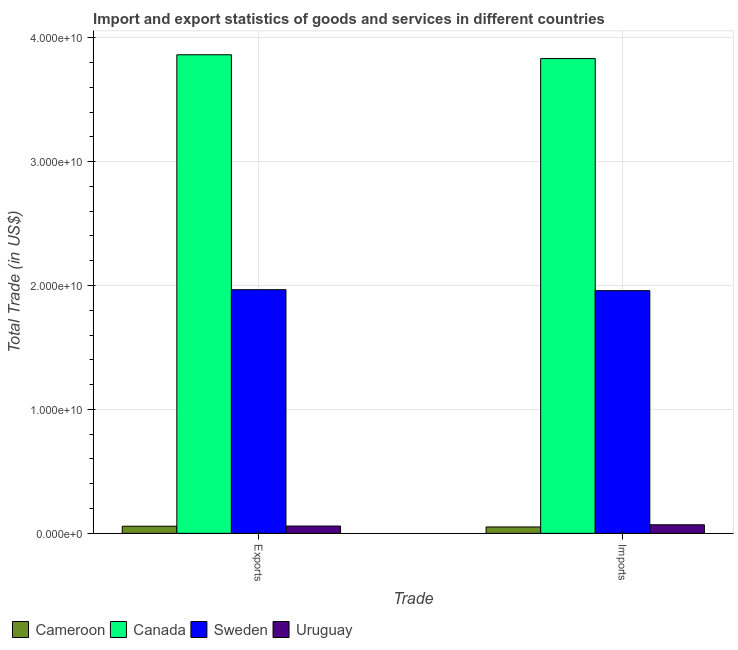How many groups of bars are there?
Your answer should be very brief. 2. Are the number of bars per tick equal to the number of legend labels?
Offer a very short reply. Yes. Are the number of bars on each tick of the X-axis equal?
Keep it short and to the point. Yes. How many bars are there on the 2nd tick from the left?
Your answer should be compact. 4. How many bars are there on the 2nd tick from the right?
Your answer should be very brief. 4. What is the label of the 2nd group of bars from the left?
Your response must be concise. Imports. What is the imports of goods and services in Sweden?
Give a very brief answer. 1.96e+1. Across all countries, what is the maximum imports of goods and services?
Make the answer very short. 3.83e+1. Across all countries, what is the minimum imports of goods and services?
Make the answer very short. 5.14e+08. In which country was the export of goods and services maximum?
Offer a very short reply. Canada. In which country was the imports of goods and services minimum?
Make the answer very short. Cameroon. What is the total export of goods and services in the graph?
Your response must be concise. 5.95e+1. What is the difference between the imports of goods and services in Cameroon and that in Uruguay?
Provide a succinct answer. -1.77e+08. What is the difference between the imports of goods and services in Uruguay and the export of goods and services in Cameroon?
Your response must be concise. 1.17e+08. What is the average imports of goods and services per country?
Ensure brevity in your answer.  1.48e+1. What is the difference between the imports of goods and services and export of goods and services in Canada?
Provide a succinct answer. -3.07e+08. What is the ratio of the imports of goods and services in Uruguay to that in Canada?
Keep it short and to the point. 0.02. What does the 1st bar from the right in Imports represents?
Offer a terse response. Uruguay. How many bars are there?
Make the answer very short. 8. Are all the bars in the graph horizontal?
Provide a succinct answer. No. What is the difference between two consecutive major ticks on the Y-axis?
Offer a very short reply. 1.00e+1. Are the values on the major ticks of Y-axis written in scientific E-notation?
Offer a very short reply. Yes. Does the graph contain any zero values?
Keep it short and to the point. No. Where does the legend appear in the graph?
Your answer should be compact. Bottom left. How many legend labels are there?
Keep it short and to the point. 4. How are the legend labels stacked?
Your answer should be compact. Horizontal. What is the title of the graph?
Keep it short and to the point. Import and export statistics of goods and services in different countries. What is the label or title of the X-axis?
Give a very brief answer. Trade. What is the label or title of the Y-axis?
Your answer should be very brief. Total Trade (in US$). What is the Total Trade (in US$) of Cameroon in Exports?
Provide a short and direct response. 5.74e+08. What is the Total Trade (in US$) in Canada in Exports?
Give a very brief answer. 3.86e+1. What is the Total Trade (in US$) in Sweden in Exports?
Give a very brief answer. 1.97e+1. What is the Total Trade (in US$) of Uruguay in Exports?
Your answer should be very brief. 5.88e+08. What is the Total Trade (in US$) of Cameroon in Imports?
Give a very brief answer. 5.14e+08. What is the Total Trade (in US$) in Canada in Imports?
Your response must be concise. 3.83e+1. What is the Total Trade (in US$) of Sweden in Imports?
Your response must be concise. 1.96e+1. What is the Total Trade (in US$) in Uruguay in Imports?
Ensure brevity in your answer.  6.91e+08. Across all Trade, what is the maximum Total Trade (in US$) in Cameroon?
Your response must be concise. 5.74e+08. Across all Trade, what is the maximum Total Trade (in US$) of Canada?
Offer a very short reply. 3.86e+1. Across all Trade, what is the maximum Total Trade (in US$) in Sweden?
Give a very brief answer. 1.97e+1. Across all Trade, what is the maximum Total Trade (in US$) of Uruguay?
Ensure brevity in your answer.  6.91e+08. Across all Trade, what is the minimum Total Trade (in US$) in Cameroon?
Give a very brief answer. 5.14e+08. Across all Trade, what is the minimum Total Trade (in US$) in Canada?
Ensure brevity in your answer.  3.83e+1. Across all Trade, what is the minimum Total Trade (in US$) of Sweden?
Your answer should be very brief. 1.96e+1. Across all Trade, what is the minimum Total Trade (in US$) in Uruguay?
Your answer should be compact. 5.88e+08. What is the total Total Trade (in US$) in Cameroon in the graph?
Ensure brevity in your answer.  1.09e+09. What is the total Total Trade (in US$) in Canada in the graph?
Ensure brevity in your answer.  7.69e+1. What is the total Total Trade (in US$) in Sweden in the graph?
Your response must be concise. 3.93e+1. What is the total Total Trade (in US$) of Uruguay in the graph?
Make the answer very short. 1.28e+09. What is the difference between the Total Trade (in US$) in Cameroon in Exports and that in Imports?
Your answer should be very brief. 5.95e+07. What is the difference between the Total Trade (in US$) of Canada in Exports and that in Imports?
Your answer should be very brief. 3.07e+08. What is the difference between the Total Trade (in US$) of Sweden in Exports and that in Imports?
Your answer should be compact. 7.82e+07. What is the difference between the Total Trade (in US$) in Uruguay in Exports and that in Imports?
Keep it short and to the point. -1.03e+08. What is the difference between the Total Trade (in US$) of Cameroon in Exports and the Total Trade (in US$) of Canada in Imports?
Your answer should be very brief. -3.77e+1. What is the difference between the Total Trade (in US$) in Cameroon in Exports and the Total Trade (in US$) in Sweden in Imports?
Provide a short and direct response. -1.90e+1. What is the difference between the Total Trade (in US$) in Cameroon in Exports and the Total Trade (in US$) in Uruguay in Imports?
Keep it short and to the point. -1.17e+08. What is the difference between the Total Trade (in US$) in Canada in Exports and the Total Trade (in US$) in Sweden in Imports?
Give a very brief answer. 1.90e+1. What is the difference between the Total Trade (in US$) in Canada in Exports and the Total Trade (in US$) in Uruguay in Imports?
Offer a terse response. 3.79e+1. What is the difference between the Total Trade (in US$) in Sweden in Exports and the Total Trade (in US$) in Uruguay in Imports?
Keep it short and to the point. 1.90e+1. What is the average Total Trade (in US$) in Cameroon per Trade?
Provide a short and direct response. 5.44e+08. What is the average Total Trade (in US$) of Canada per Trade?
Your response must be concise. 3.85e+1. What is the average Total Trade (in US$) in Sweden per Trade?
Ensure brevity in your answer.  1.96e+1. What is the average Total Trade (in US$) in Uruguay per Trade?
Make the answer very short. 6.40e+08. What is the difference between the Total Trade (in US$) in Cameroon and Total Trade (in US$) in Canada in Exports?
Your answer should be compact. -3.81e+1. What is the difference between the Total Trade (in US$) in Cameroon and Total Trade (in US$) in Sweden in Exports?
Your answer should be very brief. -1.91e+1. What is the difference between the Total Trade (in US$) of Cameroon and Total Trade (in US$) of Uruguay in Exports?
Keep it short and to the point. -1.45e+07. What is the difference between the Total Trade (in US$) in Canada and Total Trade (in US$) in Sweden in Exports?
Provide a short and direct response. 1.90e+1. What is the difference between the Total Trade (in US$) of Canada and Total Trade (in US$) of Uruguay in Exports?
Make the answer very short. 3.80e+1. What is the difference between the Total Trade (in US$) in Sweden and Total Trade (in US$) in Uruguay in Exports?
Your answer should be compact. 1.91e+1. What is the difference between the Total Trade (in US$) of Cameroon and Total Trade (in US$) of Canada in Imports?
Make the answer very short. -3.78e+1. What is the difference between the Total Trade (in US$) of Cameroon and Total Trade (in US$) of Sweden in Imports?
Offer a terse response. -1.91e+1. What is the difference between the Total Trade (in US$) in Cameroon and Total Trade (in US$) in Uruguay in Imports?
Keep it short and to the point. -1.77e+08. What is the difference between the Total Trade (in US$) of Canada and Total Trade (in US$) of Sweden in Imports?
Your answer should be very brief. 1.87e+1. What is the difference between the Total Trade (in US$) in Canada and Total Trade (in US$) in Uruguay in Imports?
Offer a very short reply. 3.76e+1. What is the difference between the Total Trade (in US$) in Sweden and Total Trade (in US$) in Uruguay in Imports?
Provide a short and direct response. 1.89e+1. What is the ratio of the Total Trade (in US$) of Cameroon in Exports to that in Imports?
Provide a succinct answer. 1.12. What is the ratio of the Total Trade (in US$) in Canada in Exports to that in Imports?
Give a very brief answer. 1.01. What is the ratio of the Total Trade (in US$) of Uruguay in Exports to that in Imports?
Your answer should be very brief. 0.85. What is the difference between the highest and the second highest Total Trade (in US$) in Cameroon?
Keep it short and to the point. 5.95e+07. What is the difference between the highest and the second highest Total Trade (in US$) in Canada?
Your response must be concise. 3.07e+08. What is the difference between the highest and the second highest Total Trade (in US$) of Sweden?
Provide a succinct answer. 7.82e+07. What is the difference between the highest and the second highest Total Trade (in US$) of Uruguay?
Make the answer very short. 1.03e+08. What is the difference between the highest and the lowest Total Trade (in US$) in Cameroon?
Your response must be concise. 5.95e+07. What is the difference between the highest and the lowest Total Trade (in US$) in Canada?
Provide a short and direct response. 3.07e+08. What is the difference between the highest and the lowest Total Trade (in US$) of Sweden?
Provide a succinct answer. 7.82e+07. What is the difference between the highest and the lowest Total Trade (in US$) in Uruguay?
Your answer should be very brief. 1.03e+08. 